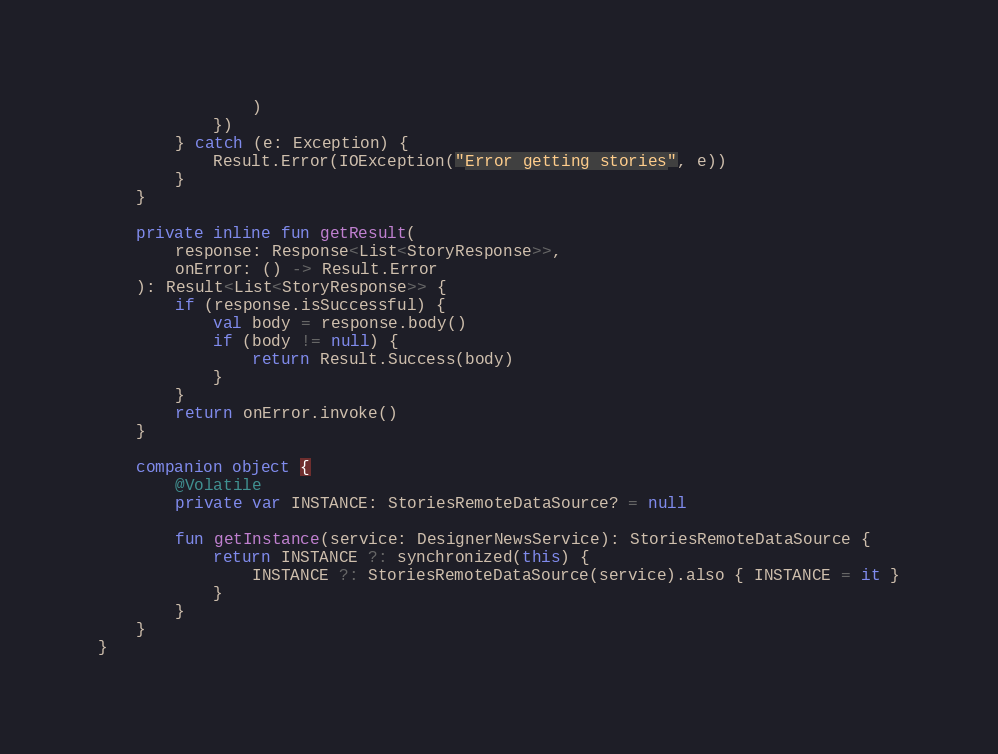Convert code to text. <code><loc_0><loc_0><loc_500><loc_500><_Kotlin_>                )
            })
        } catch (e: Exception) {
            Result.Error(IOException("Error getting stories", e))
        }
    }

    private inline fun getResult(
        response: Response<List<StoryResponse>>,
        onError: () -> Result.Error
    ): Result<List<StoryResponse>> {
        if (response.isSuccessful) {
            val body = response.body()
            if (body != null) {
                return Result.Success(body)
            }
        }
        return onError.invoke()
    }

    companion object {
        @Volatile
        private var INSTANCE: StoriesRemoteDataSource? = null

        fun getInstance(service: DesignerNewsService): StoriesRemoteDataSource {
            return INSTANCE ?: synchronized(this) {
                INSTANCE ?: StoriesRemoteDataSource(service).also { INSTANCE = it }
            }
        }
    }
}
</code> 